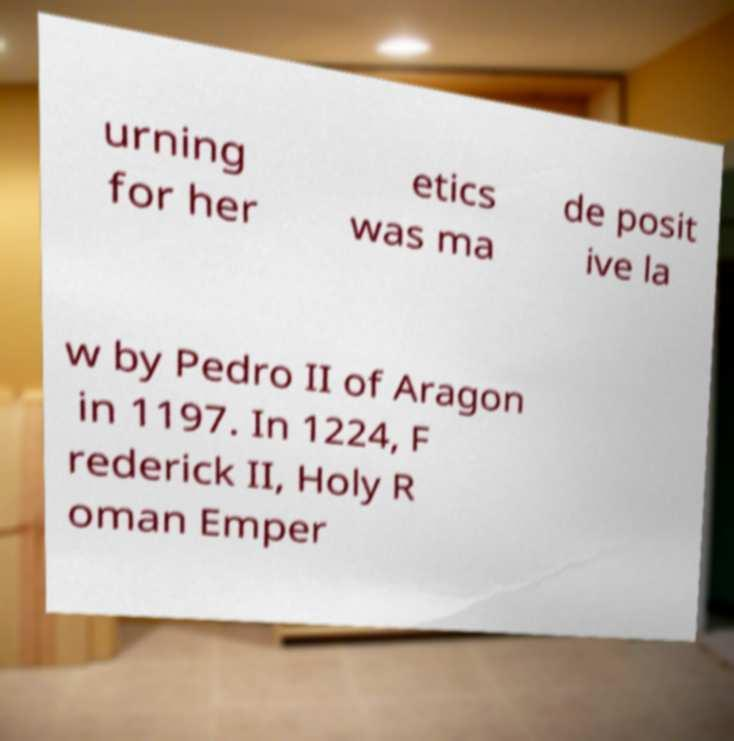Please identify and transcribe the text found in this image. urning for her etics was ma de posit ive la w by Pedro II of Aragon in 1197. In 1224, F rederick II, Holy R oman Emper 